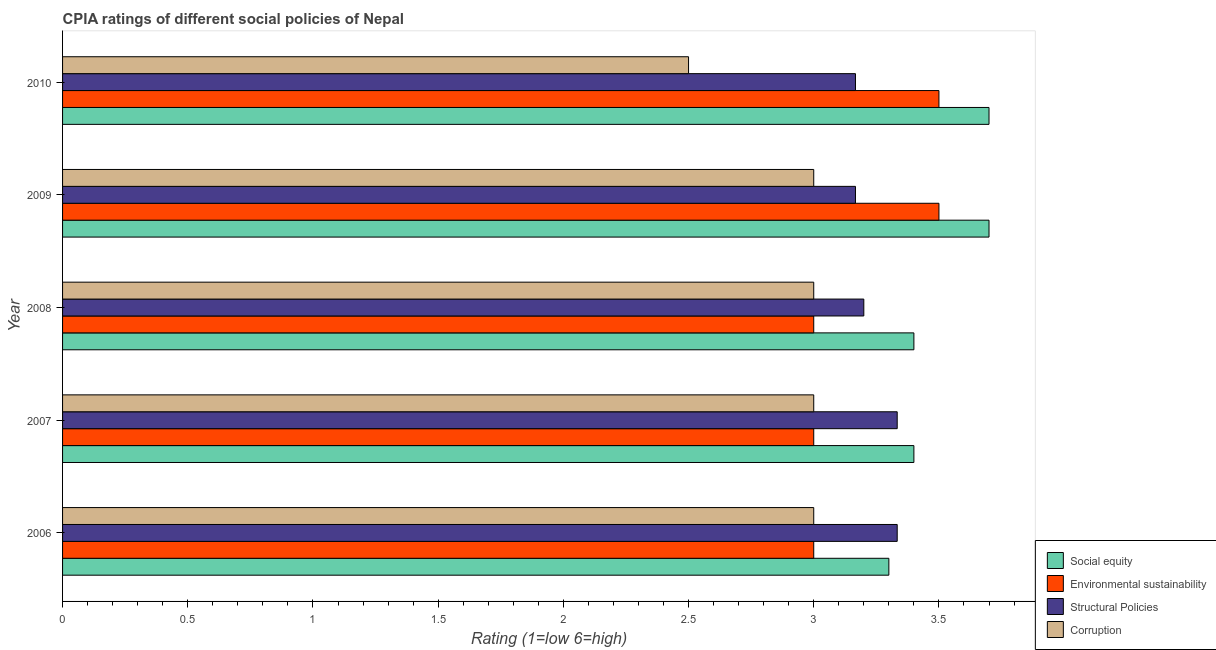How many groups of bars are there?
Offer a very short reply. 5. Are the number of bars per tick equal to the number of legend labels?
Your response must be concise. Yes. Are the number of bars on each tick of the Y-axis equal?
Give a very brief answer. Yes. How many bars are there on the 2nd tick from the top?
Keep it short and to the point. 4. Across all years, what is the maximum cpia rating of corruption?
Give a very brief answer. 3. Across all years, what is the minimum cpia rating of environmental sustainability?
Your response must be concise. 3. In which year was the cpia rating of corruption minimum?
Your response must be concise. 2010. What is the difference between the cpia rating of corruption in 2010 and the cpia rating of environmental sustainability in 2006?
Your answer should be compact. -0.5. In the year 2010, what is the difference between the cpia rating of corruption and cpia rating of environmental sustainability?
Your answer should be very brief. -1. What is the ratio of the cpia rating of social equity in 2008 to that in 2010?
Give a very brief answer. 0.92. Is the difference between the cpia rating of corruption in 2007 and 2010 greater than the difference between the cpia rating of social equity in 2007 and 2010?
Keep it short and to the point. Yes. What is the difference between the highest and the second highest cpia rating of environmental sustainability?
Your answer should be very brief. 0. Is the sum of the cpia rating of structural policies in 2008 and 2010 greater than the maximum cpia rating of social equity across all years?
Provide a succinct answer. Yes. What does the 4th bar from the top in 2009 represents?
Give a very brief answer. Social equity. What does the 4th bar from the bottom in 2008 represents?
Provide a succinct answer. Corruption. How many bars are there?
Give a very brief answer. 20. Does the graph contain any zero values?
Offer a very short reply. No. What is the title of the graph?
Ensure brevity in your answer.  CPIA ratings of different social policies of Nepal. What is the label or title of the X-axis?
Your answer should be compact. Rating (1=low 6=high). What is the label or title of the Y-axis?
Offer a terse response. Year. What is the Rating (1=low 6=high) in Structural Policies in 2006?
Provide a succinct answer. 3.33. What is the Rating (1=low 6=high) in Corruption in 2006?
Keep it short and to the point. 3. What is the Rating (1=low 6=high) of Environmental sustainability in 2007?
Provide a short and direct response. 3. What is the Rating (1=low 6=high) of Structural Policies in 2007?
Your response must be concise. 3.33. What is the Rating (1=low 6=high) of Social equity in 2008?
Offer a terse response. 3.4. What is the Rating (1=low 6=high) of Environmental sustainability in 2008?
Offer a terse response. 3. What is the Rating (1=low 6=high) in Social equity in 2009?
Your answer should be compact. 3.7. What is the Rating (1=low 6=high) in Environmental sustainability in 2009?
Keep it short and to the point. 3.5. What is the Rating (1=low 6=high) of Structural Policies in 2009?
Ensure brevity in your answer.  3.17. What is the Rating (1=low 6=high) in Corruption in 2009?
Provide a short and direct response. 3. What is the Rating (1=low 6=high) of Social equity in 2010?
Make the answer very short. 3.7. What is the Rating (1=low 6=high) of Environmental sustainability in 2010?
Make the answer very short. 3.5. What is the Rating (1=low 6=high) of Structural Policies in 2010?
Give a very brief answer. 3.17. Across all years, what is the maximum Rating (1=low 6=high) in Structural Policies?
Your answer should be compact. 3.33. Across all years, what is the minimum Rating (1=low 6=high) in Social equity?
Your response must be concise. 3.3. Across all years, what is the minimum Rating (1=low 6=high) in Environmental sustainability?
Provide a succinct answer. 3. Across all years, what is the minimum Rating (1=low 6=high) of Structural Policies?
Give a very brief answer. 3.17. What is the total Rating (1=low 6=high) in Environmental sustainability in the graph?
Make the answer very short. 16. What is the difference between the Rating (1=low 6=high) of Environmental sustainability in 2006 and that in 2007?
Make the answer very short. 0. What is the difference between the Rating (1=low 6=high) of Corruption in 2006 and that in 2007?
Your answer should be very brief. 0. What is the difference between the Rating (1=low 6=high) of Structural Policies in 2006 and that in 2008?
Your response must be concise. 0.13. What is the difference between the Rating (1=low 6=high) of Corruption in 2006 and that in 2008?
Make the answer very short. 0. What is the difference between the Rating (1=low 6=high) in Social equity in 2006 and that in 2009?
Keep it short and to the point. -0.4. What is the difference between the Rating (1=low 6=high) of Environmental sustainability in 2006 and that in 2010?
Offer a terse response. -0.5. What is the difference between the Rating (1=low 6=high) of Corruption in 2006 and that in 2010?
Your answer should be compact. 0.5. What is the difference between the Rating (1=low 6=high) of Structural Policies in 2007 and that in 2008?
Your answer should be very brief. 0.13. What is the difference between the Rating (1=low 6=high) of Corruption in 2007 and that in 2008?
Your answer should be very brief. 0. What is the difference between the Rating (1=low 6=high) of Social equity in 2007 and that in 2009?
Your answer should be compact. -0.3. What is the difference between the Rating (1=low 6=high) in Environmental sustainability in 2007 and that in 2009?
Offer a terse response. -0.5. What is the difference between the Rating (1=low 6=high) in Structural Policies in 2007 and that in 2009?
Provide a short and direct response. 0.17. What is the difference between the Rating (1=low 6=high) of Social equity in 2007 and that in 2010?
Provide a succinct answer. -0.3. What is the difference between the Rating (1=low 6=high) in Environmental sustainability in 2007 and that in 2010?
Offer a very short reply. -0.5. What is the difference between the Rating (1=low 6=high) in Structural Policies in 2007 and that in 2010?
Provide a short and direct response. 0.17. What is the difference between the Rating (1=low 6=high) in Environmental sustainability in 2008 and that in 2009?
Offer a very short reply. -0.5. What is the difference between the Rating (1=low 6=high) in Structural Policies in 2008 and that in 2009?
Offer a terse response. 0.03. What is the difference between the Rating (1=low 6=high) of Corruption in 2008 and that in 2009?
Provide a succinct answer. 0. What is the difference between the Rating (1=low 6=high) in Social equity in 2008 and that in 2010?
Give a very brief answer. -0.3. What is the difference between the Rating (1=low 6=high) in Environmental sustainability in 2008 and that in 2010?
Make the answer very short. -0.5. What is the difference between the Rating (1=low 6=high) in Structural Policies in 2008 and that in 2010?
Your answer should be very brief. 0.03. What is the difference between the Rating (1=low 6=high) in Corruption in 2008 and that in 2010?
Make the answer very short. 0.5. What is the difference between the Rating (1=low 6=high) of Environmental sustainability in 2009 and that in 2010?
Make the answer very short. 0. What is the difference between the Rating (1=low 6=high) of Structural Policies in 2009 and that in 2010?
Offer a very short reply. 0. What is the difference between the Rating (1=low 6=high) of Corruption in 2009 and that in 2010?
Ensure brevity in your answer.  0.5. What is the difference between the Rating (1=low 6=high) in Social equity in 2006 and the Rating (1=low 6=high) in Environmental sustainability in 2007?
Your answer should be compact. 0.3. What is the difference between the Rating (1=low 6=high) in Social equity in 2006 and the Rating (1=low 6=high) in Structural Policies in 2007?
Ensure brevity in your answer.  -0.03. What is the difference between the Rating (1=low 6=high) of Social equity in 2006 and the Rating (1=low 6=high) of Corruption in 2007?
Your answer should be compact. 0.3. What is the difference between the Rating (1=low 6=high) of Environmental sustainability in 2006 and the Rating (1=low 6=high) of Structural Policies in 2007?
Your response must be concise. -0.33. What is the difference between the Rating (1=low 6=high) of Structural Policies in 2006 and the Rating (1=low 6=high) of Corruption in 2007?
Ensure brevity in your answer.  0.33. What is the difference between the Rating (1=low 6=high) in Social equity in 2006 and the Rating (1=low 6=high) in Corruption in 2008?
Give a very brief answer. 0.3. What is the difference between the Rating (1=low 6=high) in Environmental sustainability in 2006 and the Rating (1=low 6=high) in Corruption in 2008?
Make the answer very short. 0. What is the difference between the Rating (1=low 6=high) of Social equity in 2006 and the Rating (1=low 6=high) of Environmental sustainability in 2009?
Keep it short and to the point. -0.2. What is the difference between the Rating (1=low 6=high) of Social equity in 2006 and the Rating (1=low 6=high) of Structural Policies in 2009?
Keep it short and to the point. 0.13. What is the difference between the Rating (1=low 6=high) in Social equity in 2006 and the Rating (1=low 6=high) in Corruption in 2009?
Your response must be concise. 0.3. What is the difference between the Rating (1=low 6=high) of Environmental sustainability in 2006 and the Rating (1=low 6=high) of Structural Policies in 2009?
Offer a terse response. -0.17. What is the difference between the Rating (1=low 6=high) of Social equity in 2006 and the Rating (1=low 6=high) of Structural Policies in 2010?
Your answer should be very brief. 0.13. What is the difference between the Rating (1=low 6=high) of Social equity in 2006 and the Rating (1=low 6=high) of Corruption in 2010?
Offer a very short reply. 0.8. What is the difference between the Rating (1=low 6=high) in Environmental sustainability in 2006 and the Rating (1=low 6=high) in Corruption in 2010?
Give a very brief answer. 0.5. What is the difference between the Rating (1=low 6=high) of Structural Policies in 2006 and the Rating (1=low 6=high) of Corruption in 2010?
Ensure brevity in your answer.  0.83. What is the difference between the Rating (1=low 6=high) of Social equity in 2007 and the Rating (1=low 6=high) of Corruption in 2008?
Make the answer very short. 0.4. What is the difference between the Rating (1=low 6=high) in Structural Policies in 2007 and the Rating (1=low 6=high) in Corruption in 2008?
Offer a very short reply. 0.33. What is the difference between the Rating (1=low 6=high) in Social equity in 2007 and the Rating (1=low 6=high) in Environmental sustainability in 2009?
Your answer should be very brief. -0.1. What is the difference between the Rating (1=low 6=high) in Social equity in 2007 and the Rating (1=low 6=high) in Structural Policies in 2009?
Provide a short and direct response. 0.23. What is the difference between the Rating (1=low 6=high) in Environmental sustainability in 2007 and the Rating (1=low 6=high) in Structural Policies in 2009?
Provide a succinct answer. -0.17. What is the difference between the Rating (1=low 6=high) in Environmental sustainability in 2007 and the Rating (1=low 6=high) in Corruption in 2009?
Give a very brief answer. 0. What is the difference between the Rating (1=low 6=high) of Social equity in 2007 and the Rating (1=low 6=high) of Environmental sustainability in 2010?
Offer a terse response. -0.1. What is the difference between the Rating (1=low 6=high) in Social equity in 2007 and the Rating (1=low 6=high) in Structural Policies in 2010?
Your answer should be very brief. 0.23. What is the difference between the Rating (1=low 6=high) in Environmental sustainability in 2007 and the Rating (1=low 6=high) in Corruption in 2010?
Your answer should be very brief. 0.5. What is the difference between the Rating (1=low 6=high) in Structural Policies in 2007 and the Rating (1=low 6=high) in Corruption in 2010?
Provide a succinct answer. 0.83. What is the difference between the Rating (1=low 6=high) of Social equity in 2008 and the Rating (1=low 6=high) of Structural Policies in 2009?
Provide a succinct answer. 0.23. What is the difference between the Rating (1=low 6=high) in Environmental sustainability in 2008 and the Rating (1=low 6=high) in Structural Policies in 2009?
Your answer should be compact. -0.17. What is the difference between the Rating (1=low 6=high) in Structural Policies in 2008 and the Rating (1=low 6=high) in Corruption in 2009?
Your answer should be very brief. 0.2. What is the difference between the Rating (1=low 6=high) of Social equity in 2008 and the Rating (1=low 6=high) of Environmental sustainability in 2010?
Offer a very short reply. -0.1. What is the difference between the Rating (1=low 6=high) in Social equity in 2008 and the Rating (1=low 6=high) in Structural Policies in 2010?
Ensure brevity in your answer.  0.23. What is the difference between the Rating (1=low 6=high) in Social equity in 2008 and the Rating (1=low 6=high) in Corruption in 2010?
Your response must be concise. 0.9. What is the difference between the Rating (1=low 6=high) of Environmental sustainability in 2008 and the Rating (1=low 6=high) of Structural Policies in 2010?
Make the answer very short. -0.17. What is the difference between the Rating (1=low 6=high) of Structural Policies in 2008 and the Rating (1=low 6=high) of Corruption in 2010?
Your answer should be very brief. 0.7. What is the difference between the Rating (1=low 6=high) of Social equity in 2009 and the Rating (1=low 6=high) of Structural Policies in 2010?
Give a very brief answer. 0.53. What is the difference between the Rating (1=low 6=high) of Social equity in 2009 and the Rating (1=low 6=high) of Corruption in 2010?
Offer a very short reply. 1.2. What is the difference between the Rating (1=low 6=high) in Environmental sustainability in 2009 and the Rating (1=low 6=high) in Corruption in 2010?
Offer a very short reply. 1. What is the average Rating (1=low 6=high) of Environmental sustainability per year?
Offer a terse response. 3.2. What is the average Rating (1=low 6=high) in Structural Policies per year?
Offer a very short reply. 3.24. What is the average Rating (1=low 6=high) of Corruption per year?
Your answer should be very brief. 2.9. In the year 2006, what is the difference between the Rating (1=low 6=high) of Social equity and Rating (1=low 6=high) of Structural Policies?
Your answer should be compact. -0.03. In the year 2006, what is the difference between the Rating (1=low 6=high) of Social equity and Rating (1=low 6=high) of Corruption?
Your answer should be very brief. 0.3. In the year 2006, what is the difference between the Rating (1=low 6=high) of Environmental sustainability and Rating (1=low 6=high) of Structural Policies?
Keep it short and to the point. -0.33. In the year 2007, what is the difference between the Rating (1=low 6=high) in Social equity and Rating (1=low 6=high) in Structural Policies?
Make the answer very short. 0.07. In the year 2007, what is the difference between the Rating (1=low 6=high) in Environmental sustainability and Rating (1=low 6=high) in Structural Policies?
Make the answer very short. -0.33. In the year 2007, what is the difference between the Rating (1=low 6=high) in Environmental sustainability and Rating (1=low 6=high) in Corruption?
Offer a very short reply. 0. In the year 2008, what is the difference between the Rating (1=low 6=high) in Social equity and Rating (1=low 6=high) in Structural Policies?
Provide a succinct answer. 0.2. In the year 2008, what is the difference between the Rating (1=low 6=high) in Social equity and Rating (1=low 6=high) in Corruption?
Your answer should be very brief. 0.4. In the year 2008, what is the difference between the Rating (1=low 6=high) in Environmental sustainability and Rating (1=low 6=high) in Structural Policies?
Offer a terse response. -0.2. In the year 2008, what is the difference between the Rating (1=low 6=high) in Structural Policies and Rating (1=low 6=high) in Corruption?
Your response must be concise. 0.2. In the year 2009, what is the difference between the Rating (1=low 6=high) in Social equity and Rating (1=low 6=high) in Structural Policies?
Your response must be concise. 0.53. In the year 2009, what is the difference between the Rating (1=low 6=high) of Social equity and Rating (1=low 6=high) of Corruption?
Provide a succinct answer. 0.7. In the year 2009, what is the difference between the Rating (1=low 6=high) in Environmental sustainability and Rating (1=low 6=high) in Corruption?
Your answer should be compact. 0.5. In the year 2009, what is the difference between the Rating (1=low 6=high) in Structural Policies and Rating (1=low 6=high) in Corruption?
Offer a terse response. 0.17. In the year 2010, what is the difference between the Rating (1=low 6=high) of Social equity and Rating (1=low 6=high) of Environmental sustainability?
Your answer should be very brief. 0.2. In the year 2010, what is the difference between the Rating (1=low 6=high) in Social equity and Rating (1=low 6=high) in Structural Policies?
Your response must be concise. 0.53. In the year 2010, what is the difference between the Rating (1=low 6=high) of Environmental sustainability and Rating (1=low 6=high) of Structural Policies?
Your answer should be compact. 0.33. In the year 2010, what is the difference between the Rating (1=low 6=high) in Structural Policies and Rating (1=low 6=high) in Corruption?
Give a very brief answer. 0.67. What is the ratio of the Rating (1=low 6=high) of Social equity in 2006 to that in 2007?
Your response must be concise. 0.97. What is the ratio of the Rating (1=low 6=high) in Environmental sustainability in 2006 to that in 2007?
Provide a short and direct response. 1. What is the ratio of the Rating (1=low 6=high) in Social equity in 2006 to that in 2008?
Your answer should be compact. 0.97. What is the ratio of the Rating (1=low 6=high) in Structural Policies in 2006 to that in 2008?
Offer a terse response. 1.04. What is the ratio of the Rating (1=low 6=high) of Social equity in 2006 to that in 2009?
Your answer should be compact. 0.89. What is the ratio of the Rating (1=low 6=high) in Environmental sustainability in 2006 to that in 2009?
Your answer should be very brief. 0.86. What is the ratio of the Rating (1=low 6=high) in Structural Policies in 2006 to that in 2009?
Offer a terse response. 1.05. What is the ratio of the Rating (1=low 6=high) in Corruption in 2006 to that in 2009?
Give a very brief answer. 1. What is the ratio of the Rating (1=low 6=high) of Social equity in 2006 to that in 2010?
Ensure brevity in your answer.  0.89. What is the ratio of the Rating (1=low 6=high) of Structural Policies in 2006 to that in 2010?
Your response must be concise. 1.05. What is the ratio of the Rating (1=low 6=high) in Corruption in 2006 to that in 2010?
Your answer should be very brief. 1.2. What is the ratio of the Rating (1=low 6=high) of Social equity in 2007 to that in 2008?
Offer a terse response. 1. What is the ratio of the Rating (1=low 6=high) of Environmental sustainability in 2007 to that in 2008?
Ensure brevity in your answer.  1. What is the ratio of the Rating (1=low 6=high) in Structural Policies in 2007 to that in 2008?
Provide a short and direct response. 1.04. What is the ratio of the Rating (1=low 6=high) of Social equity in 2007 to that in 2009?
Provide a succinct answer. 0.92. What is the ratio of the Rating (1=low 6=high) of Environmental sustainability in 2007 to that in 2009?
Provide a short and direct response. 0.86. What is the ratio of the Rating (1=low 6=high) of Structural Policies in 2007 to that in 2009?
Ensure brevity in your answer.  1.05. What is the ratio of the Rating (1=low 6=high) in Social equity in 2007 to that in 2010?
Your answer should be very brief. 0.92. What is the ratio of the Rating (1=low 6=high) in Environmental sustainability in 2007 to that in 2010?
Make the answer very short. 0.86. What is the ratio of the Rating (1=low 6=high) in Structural Policies in 2007 to that in 2010?
Your answer should be compact. 1.05. What is the ratio of the Rating (1=low 6=high) in Social equity in 2008 to that in 2009?
Ensure brevity in your answer.  0.92. What is the ratio of the Rating (1=low 6=high) of Structural Policies in 2008 to that in 2009?
Ensure brevity in your answer.  1.01. What is the ratio of the Rating (1=low 6=high) in Social equity in 2008 to that in 2010?
Give a very brief answer. 0.92. What is the ratio of the Rating (1=low 6=high) in Structural Policies in 2008 to that in 2010?
Make the answer very short. 1.01. What is the ratio of the Rating (1=low 6=high) in Structural Policies in 2009 to that in 2010?
Keep it short and to the point. 1. What is the ratio of the Rating (1=low 6=high) of Corruption in 2009 to that in 2010?
Give a very brief answer. 1.2. What is the difference between the highest and the second highest Rating (1=low 6=high) in Structural Policies?
Keep it short and to the point. 0. What is the difference between the highest and the lowest Rating (1=low 6=high) in Structural Policies?
Keep it short and to the point. 0.17. What is the difference between the highest and the lowest Rating (1=low 6=high) in Corruption?
Offer a terse response. 0.5. 